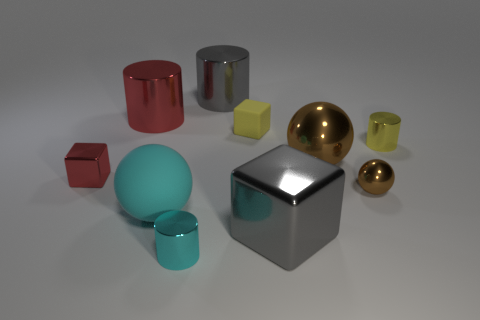Subtract all big gray metal cylinders. How many cylinders are left? 3 Subtract all yellow cylinders. How many brown balls are left? 2 Subtract all cyan cylinders. How many cylinders are left? 3 Subtract 1 blocks. How many blocks are left? 2 Subtract all blue cylinders. Subtract all purple cubes. How many cylinders are left? 4 Subtract all spheres. How many objects are left? 7 Add 6 green rubber cylinders. How many green rubber cylinders exist? 6 Subtract 1 brown spheres. How many objects are left? 9 Subtract all large cyan metallic things. Subtract all shiny blocks. How many objects are left? 8 Add 3 matte blocks. How many matte blocks are left? 4 